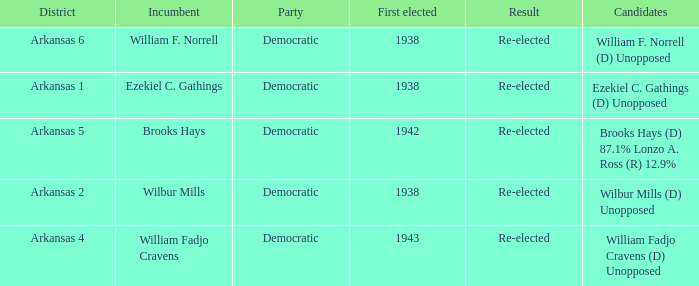What is the earliest years any of the incumbents were first elected?  1938.0. 